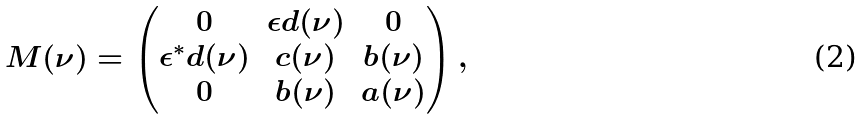<formula> <loc_0><loc_0><loc_500><loc_500>M ( \nu ) = \begin{pmatrix} 0 & \epsilon d ( \nu ) & 0 \\ \epsilon ^ { * } d ( \nu ) & c ( \nu ) & b ( \nu ) \\ 0 & b ( \nu ) & a ( \nu ) \end{pmatrix} ,</formula> 